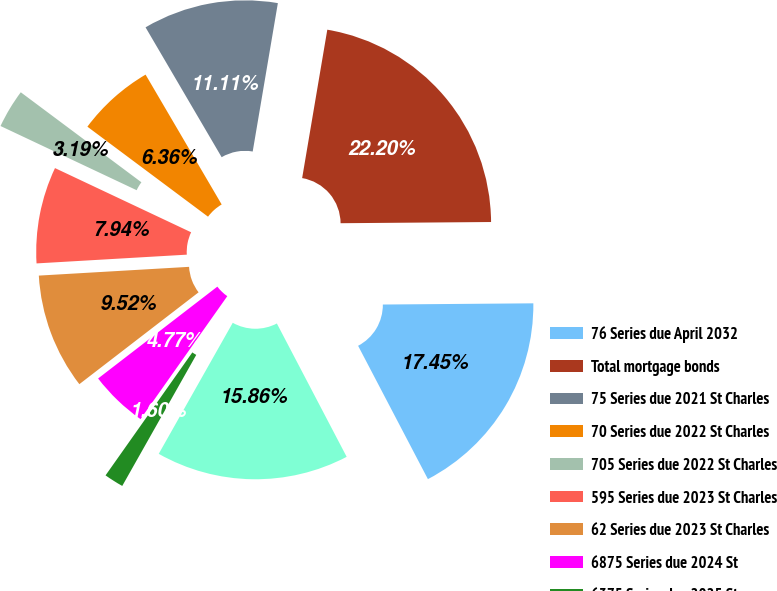Convert chart. <chart><loc_0><loc_0><loc_500><loc_500><pie_chart><fcel>76 Series due April 2032<fcel>Total mortgage bonds<fcel>75 Series due 2021 St Charles<fcel>70 Series due 2022 St Charles<fcel>705 Series due 2022 St Charles<fcel>595 Series due 2023 St Charles<fcel>62 Series due 2023 St Charles<fcel>6875 Series due 2024 St<fcel>6375 Series due 2025 St<fcel>Auction Rate due 2030 St<nl><fcel>17.45%<fcel>22.2%<fcel>11.11%<fcel>6.36%<fcel>3.19%<fcel>7.94%<fcel>9.52%<fcel>4.77%<fcel>1.6%<fcel>15.86%<nl></chart> 